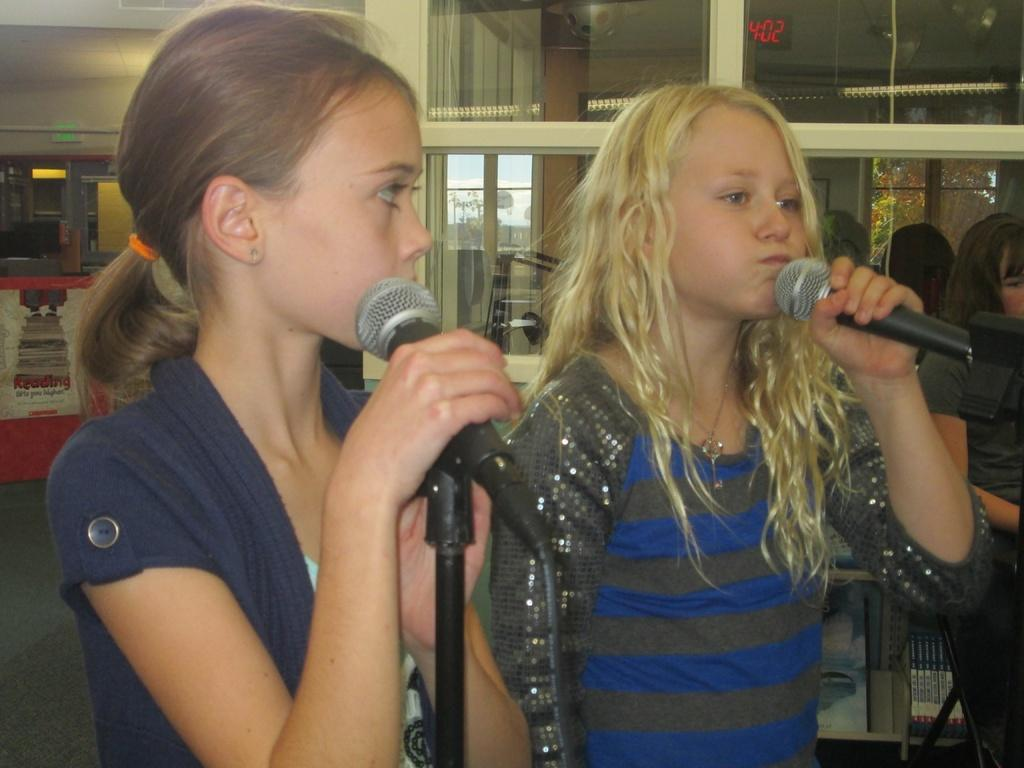How many people are in the image? There are two girls in the image. What are the girls holding in the image? The girls are holding microphones. What are the girls doing in the image? The girls are talking. Can you describe the woman in the image? There is a woman on the right side of the image. What type of cloud can be seen in the image? There is no cloud present in the image. What ingredients are used to make the stew in the image? There is no stew present in the image. 